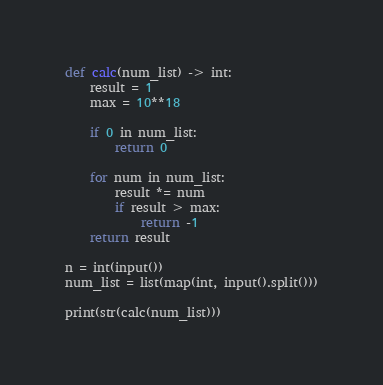<code> <loc_0><loc_0><loc_500><loc_500><_Python_>def calc(num_list) -> int:
    result = 1
    max = 10**18

    if 0 in num_list:
        return 0

    for num in num_list:
        result *= num
        if result > max:
            return -1
    return result

n = int(input())
num_list = list(map(int, input().split()))

print(str(calc(num_list)))</code> 